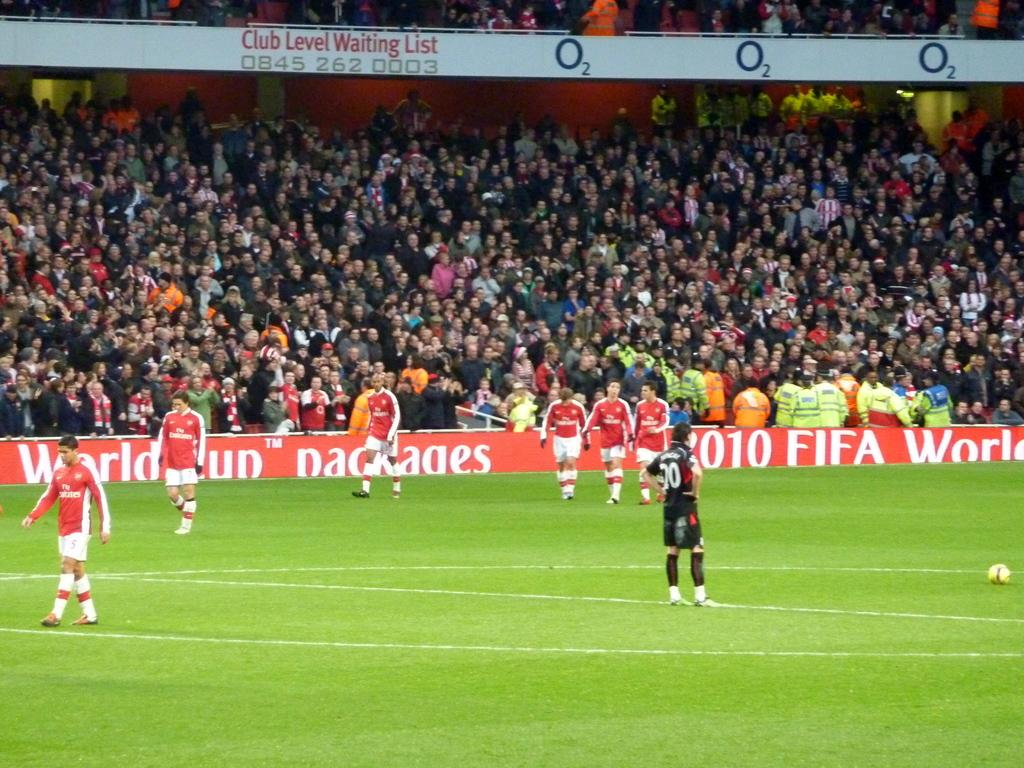What sport are the people playing in the image? The people are playing football in the image. Where is the football game taking place? The football game is taking place on a ground. Can you describe the people who are not playing in the image? Many people are seated at the back of the image. What type of coast can be seen in the image? There is no coast present in the image; it features a football game taking place on a ground. Can you tell me how many desks are visible in the image? There are no desks present in the image. 